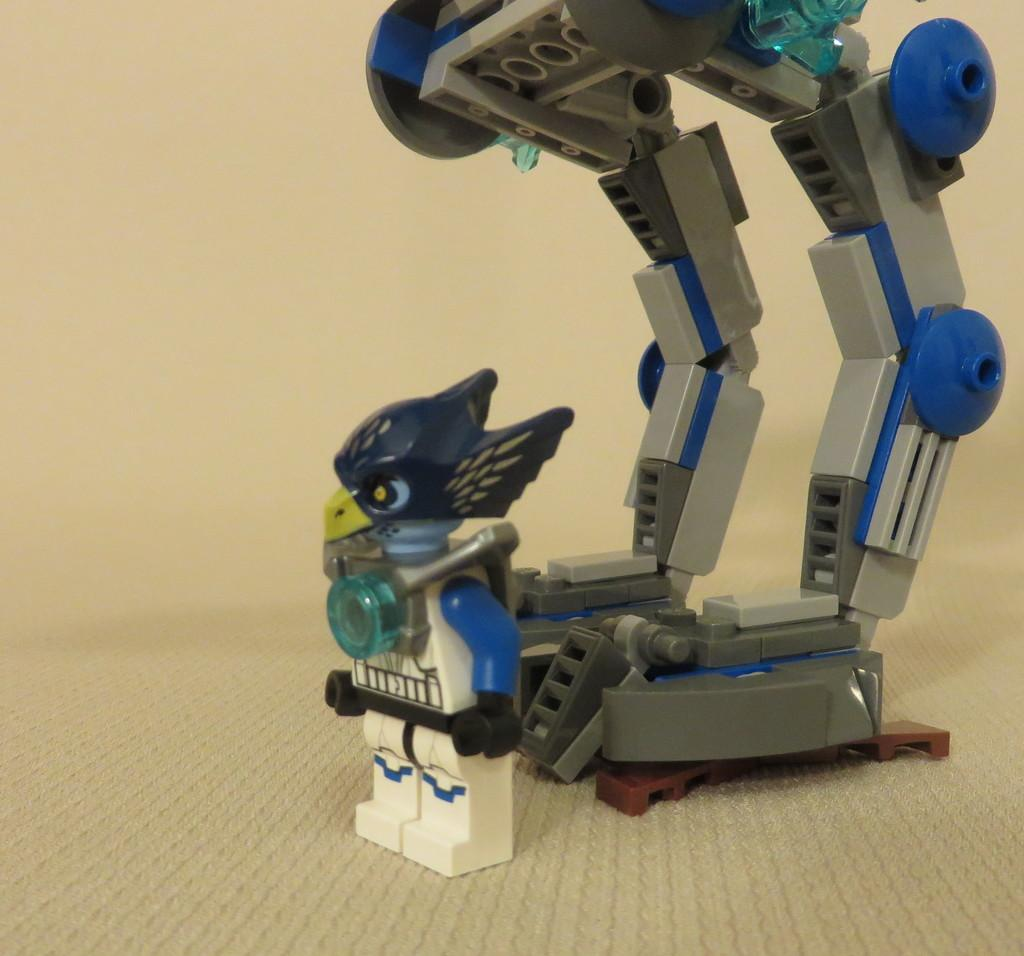What is the main subject in the image? There is a robot in the image. What material is the robot made of? The robot is made of plastic. Where is the robot located in the image? The robot is on the floor. What can be seen in the background of the image? The background of the image includes a wall. What color is the wall in the image? The wall is in cream color. What colors are the robot's body parts? The robot is in blue and grey color. Can you see any jellyfish swimming near the robot in the image? No, there are no jellyfish present in the image. Is there a cave visible in the background of the image? No, there is no cave visible in the image; only a wall is present in the background. 